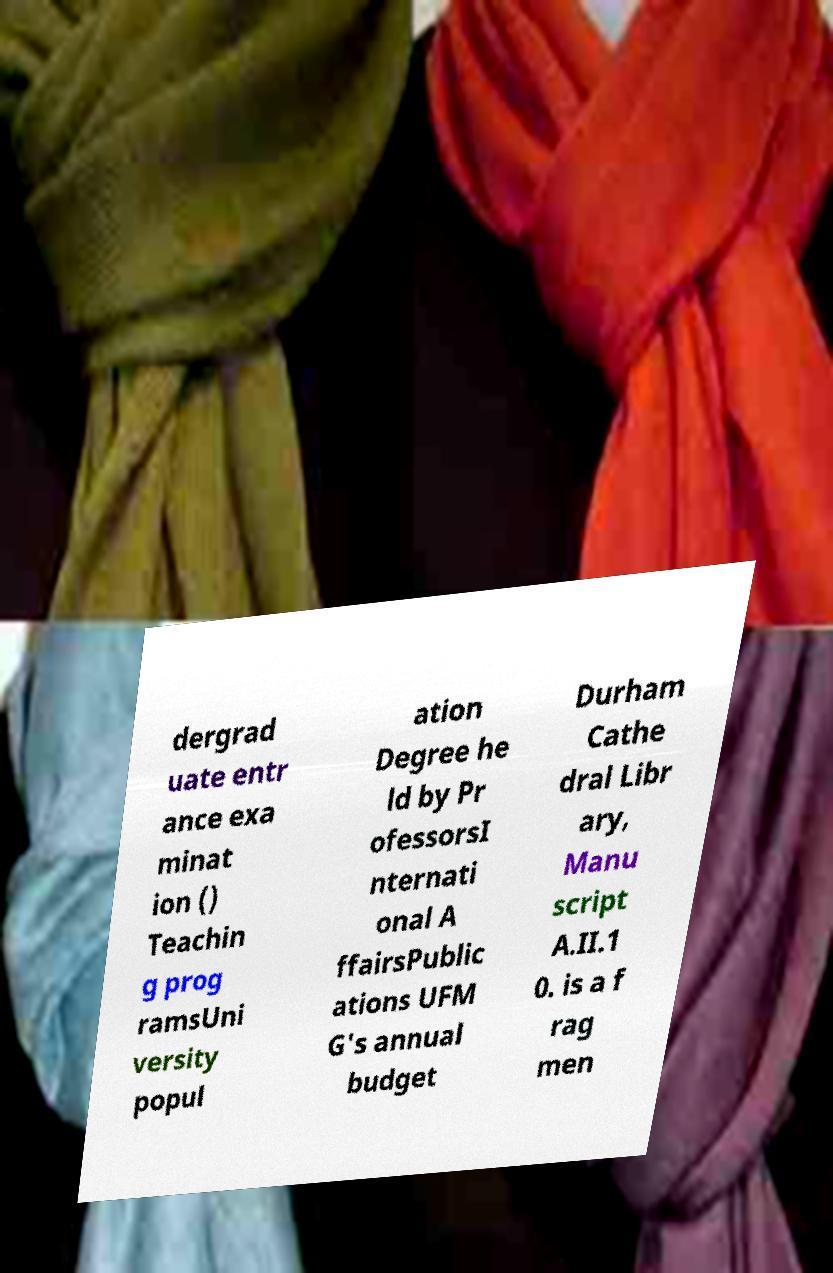For documentation purposes, I need the text within this image transcribed. Could you provide that? dergrad uate entr ance exa minat ion () Teachin g prog ramsUni versity popul ation Degree he ld by Pr ofessorsI nternati onal A ffairsPublic ations UFM G's annual budget Durham Cathe dral Libr ary, Manu script A.II.1 0. is a f rag men 